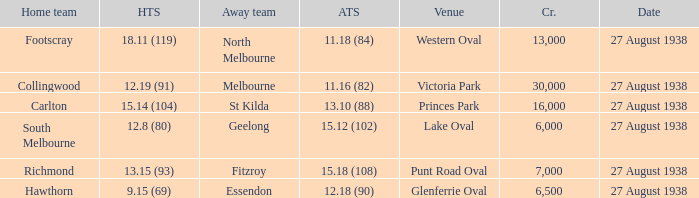Which away team scored 12.18 (90)? Essendon. 